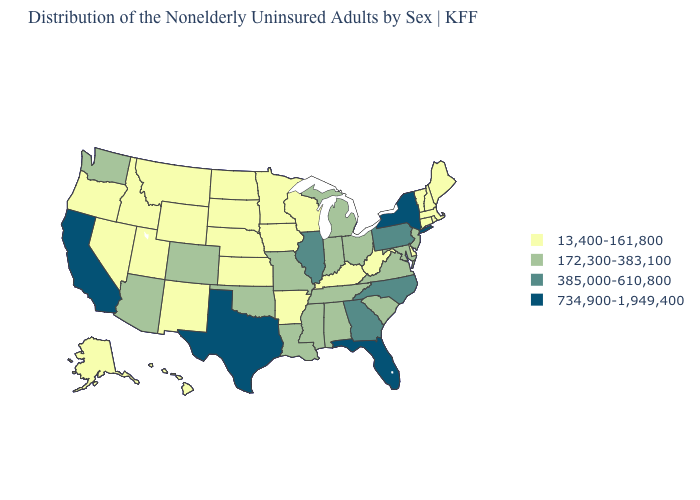Name the states that have a value in the range 734,900-1,949,400?
Answer briefly. California, Florida, New York, Texas. What is the value of Rhode Island?
Concise answer only. 13,400-161,800. Name the states that have a value in the range 734,900-1,949,400?
Write a very short answer. California, Florida, New York, Texas. What is the value of Washington?
Give a very brief answer. 172,300-383,100. Does Alabama have the same value as Nevada?
Be succinct. No. Which states hav the highest value in the West?
Be succinct. California. Does South Carolina have the lowest value in the USA?
Answer briefly. No. Does the first symbol in the legend represent the smallest category?
Concise answer only. Yes. Which states have the lowest value in the USA?
Short answer required. Alaska, Arkansas, Connecticut, Delaware, Hawaii, Idaho, Iowa, Kansas, Kentucky, Maine, Massachusetts, Minnesota, Montana, Nebraska, Nevada, New Hampshire, New Mexico, North Dakota, Oregon, Rhode Island, South Dakota, Utah, Vermont, West Virginia, Wisconsin, Wyoming. What is the highest value in the USA?
Write a very short answer. 734,900-1,949,400. What is the lowest value in states that border Pennsylvania?
Quick response, please. 13,400-161,800. Among the states that border Indiana , which have the lowest value?
Keep it brief. Kentucky. Name the states that have a value in the range 172,300-383,100?
Short answer required. Alabama, Arizona, Colorado, Indiana, Louisiana, Maryland, Michigan, Mississippi, Missouri, New Jersey, Ohio, Oklahoma, South Carolina, Tennessee, Virginia, Washington. What is the highest value in the USA?
Short answer required. 734,900-1,949,400. What is the lowest value in the South?
Answer briefly. 13,400-161,800. 